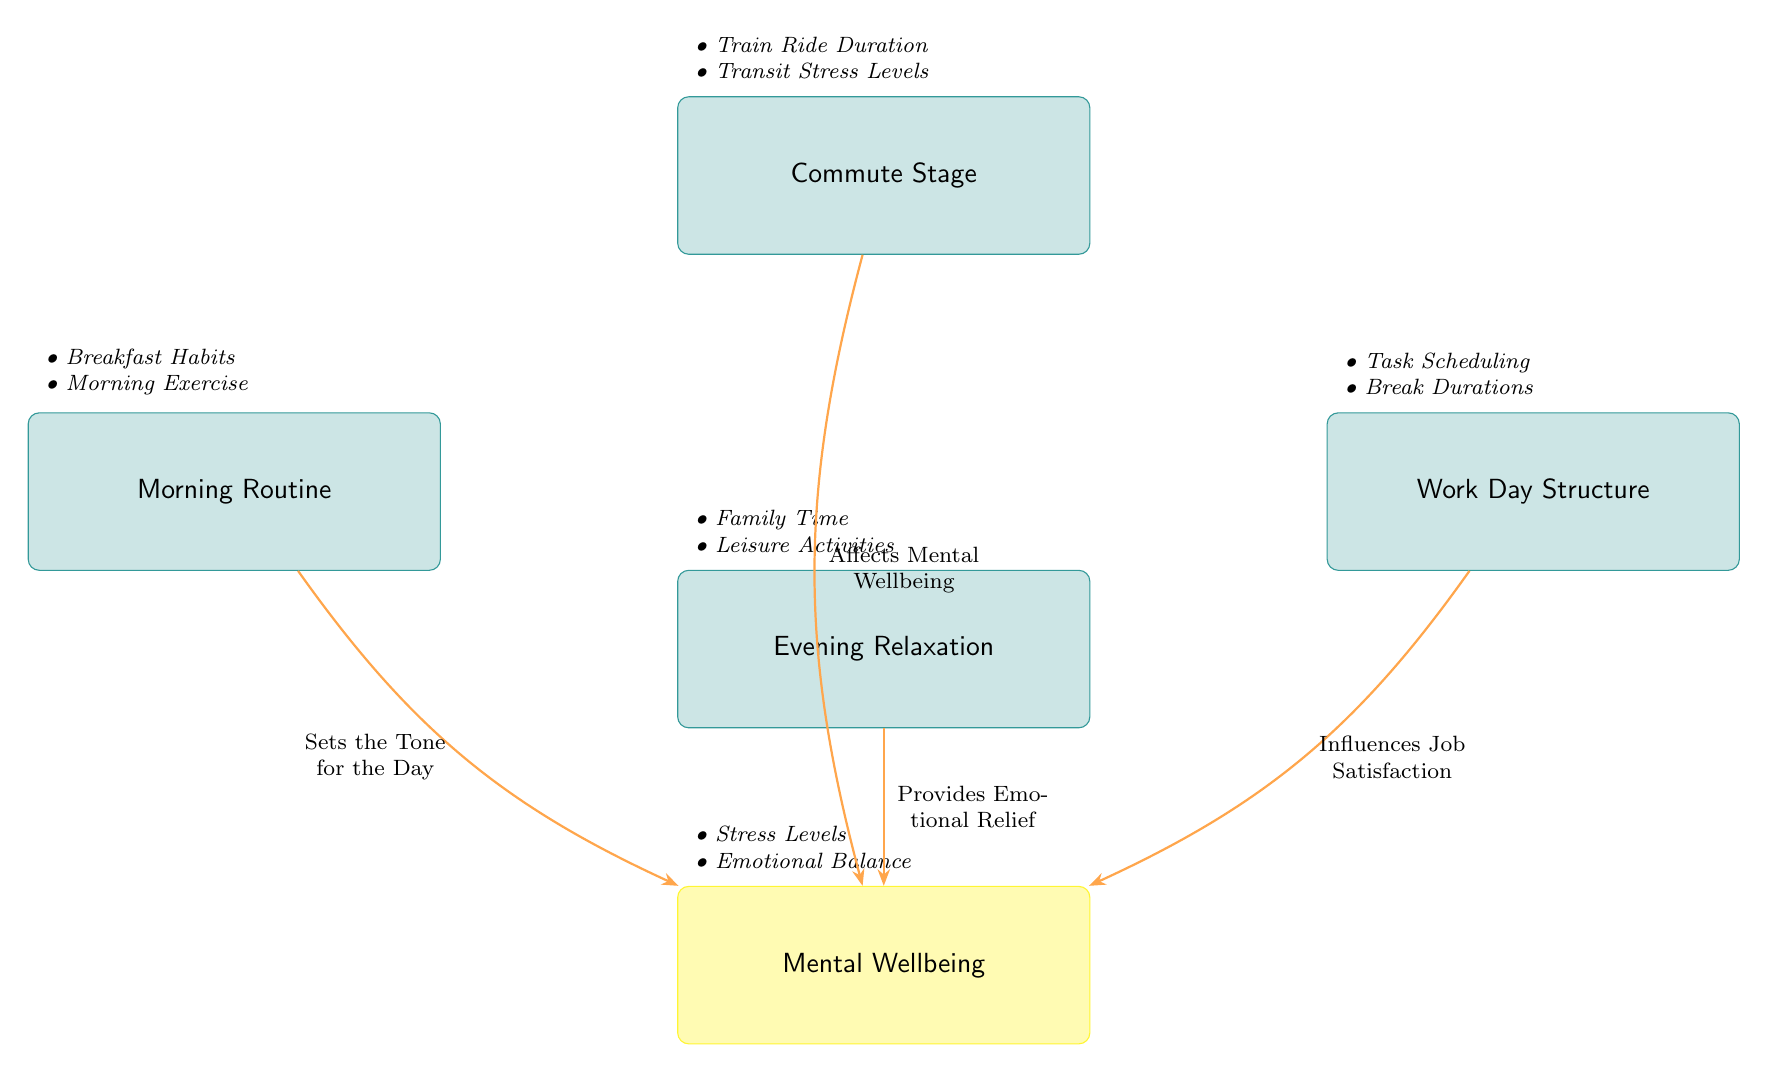What are the four main stages depicted in the diagram? The diagram displays four distinct stages: Commute Stage, Morning Routine, Work Day Structure, and Evening Relaxation. Each stage is represented by a box in the diagram.
Answer: Commute Stage, Morning Routine, Work Day Structure, Evening Relaxation How many arrows are present in the diagram? There are four arrows connecting the stages to the Mental Wellbeing node, indicating the influence of each stage on mental wellbeing.
Answer: 4 What does the Morning Routine affect? The arrow from the Morning Routine points towards the Mental Wellbeing node, indicating that it sets the tone for the day and impacts mental wellbeing.
Answer: Mental Wellbeing Which stage provides emotional relief? The Evening Relaxation stage has an arrow pointing toward the Mental Wellbeing node, labeled as providing emotional relief.
Answer: Evening Relaxation What are the details associated with the Work Day Structure? The details listed under Work Day Structure include Task Scheduling and Break Durations, which contribute to how the workday is structured.
Answer: Task Scheduling, Break Durations Which stage influences job satisfaction? The arrow from the Work Day Structure indicates that it influences job satisfaction, directly connecting to the Mental Wellbeing node.
Answer: Work Day Structure What is the relationship between the Commute Stage and Mental Wellbeing? The Commute Stage has an arrow that bends to the Mental Wellbeing node, labeled "Affects Mental Wellbeing," showing its impact on mental state.
Answer: Affects Mental Wellbeing What contributes to the details of Evening Relaxation? The details listed for Evening Relaxation are Family Time and Leisure Activities, which are crucial for relaxation.
Answer: Family Time, Leisure Activities How does the diagram classify the effect of the train ride duration? The diagram categorizes the train ride duration as part of the Commute Stage, which affects the overall mental wellbeing of the individual.
Answer: Commute Stage 